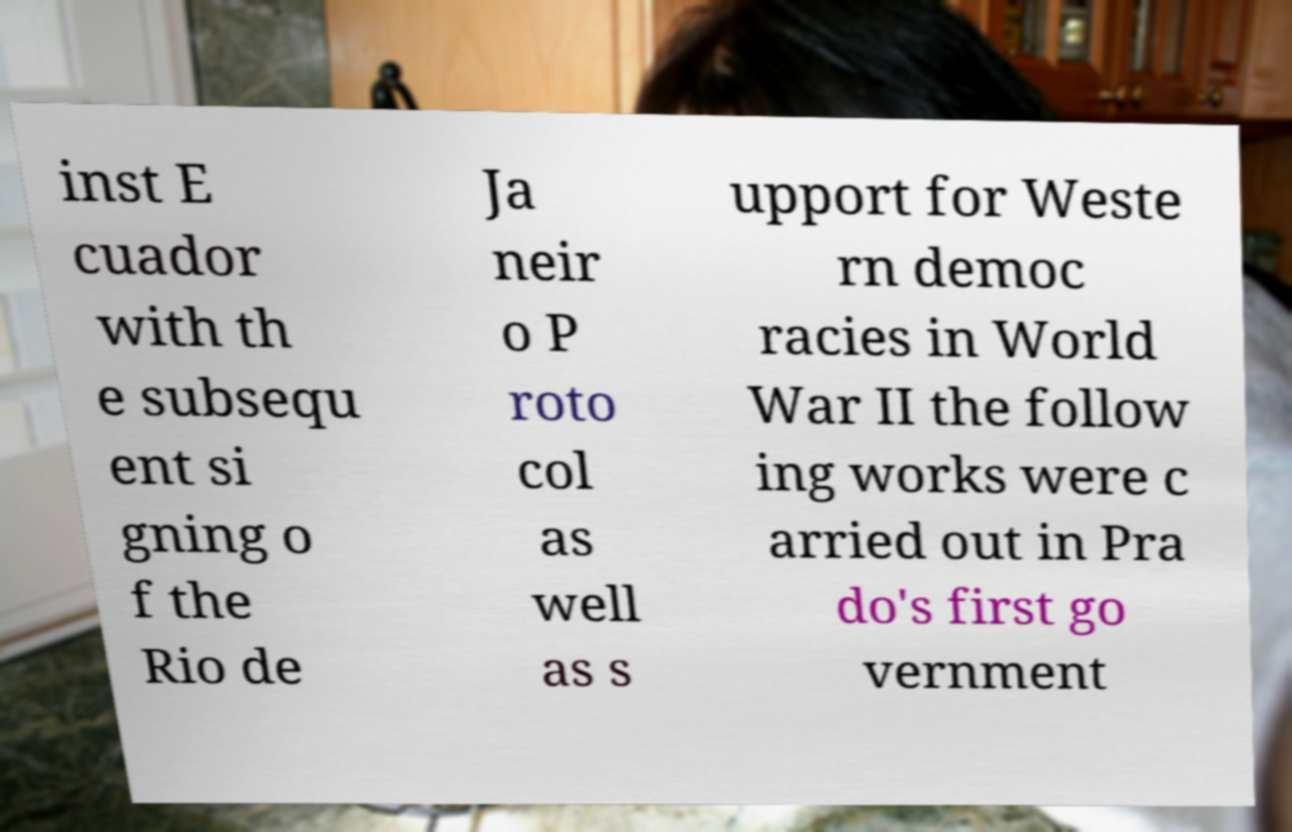Could you assist in decoding the text presented in this image and type it out clearly? inst E cuador with th e subsequ ent si gning o f the Rio de Ja neir o P roto col as well as s upport for Weste rn democ racies in World War II the follow ing works were c arried out in Pra do's first go vernment 